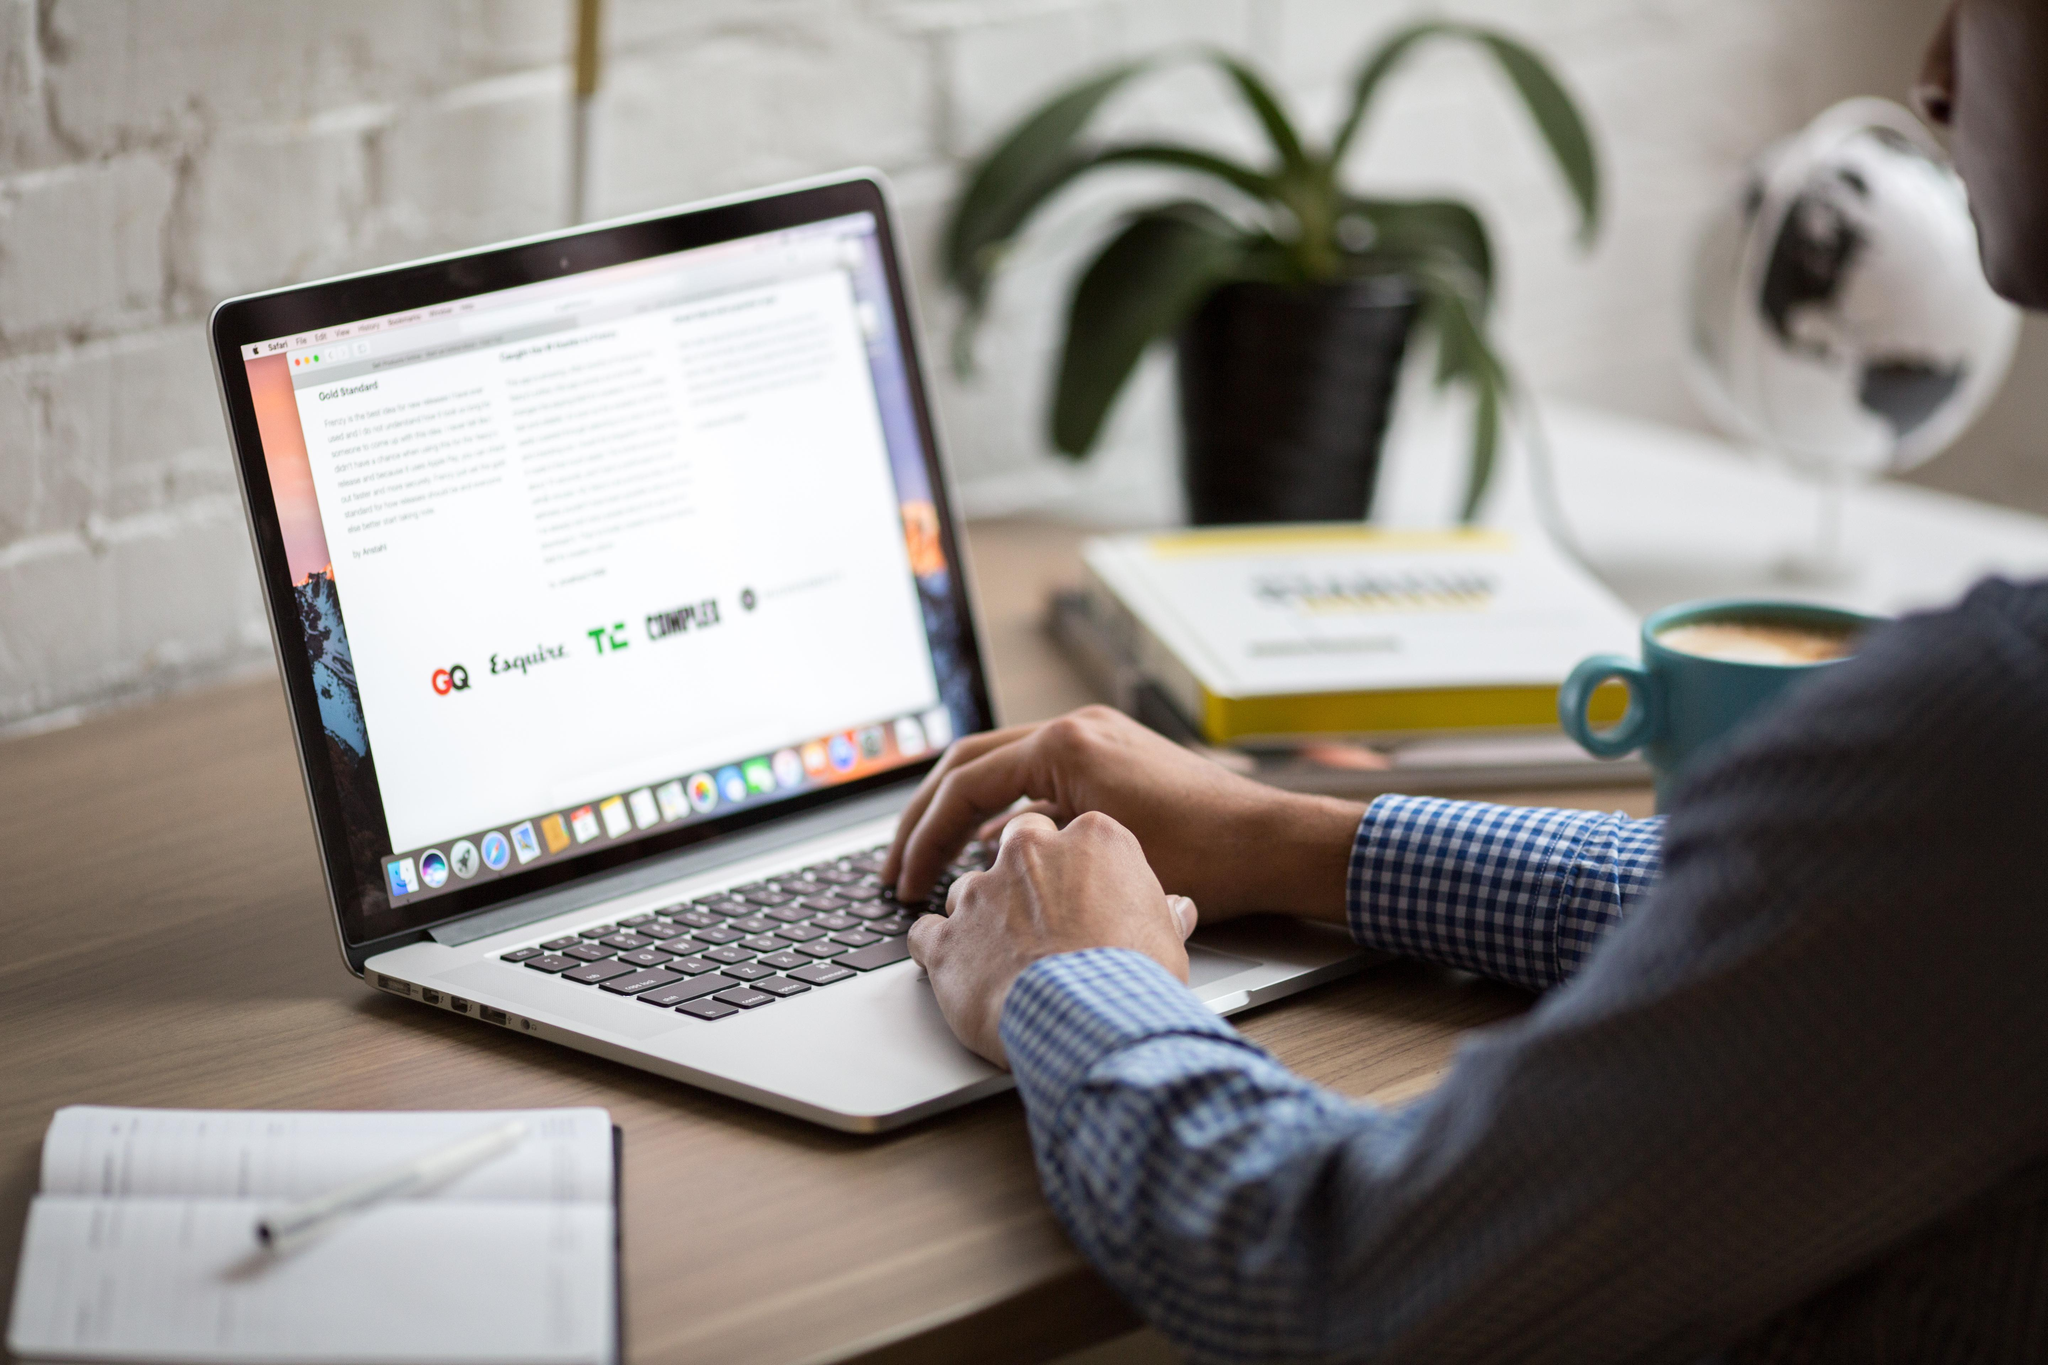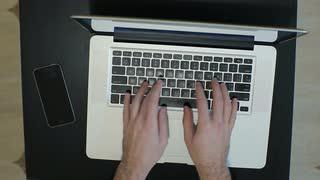The first image is the image on the left, the second image is the image on the right. Examine the images to the left and right. Is the description "In each image, a person's hands are on a laptop keyboard that has black keys on an otherwise light-colored surface." accurate? Answer yes or no. Yes. The first image is the image on the left, the second image is the image on the right. Given the left and right images, does the statement "Each image features a pair of hands over a keyboard, and the right image is an aerial view showing fingers over the black keyboard keys of one laptop." hold true? Answer yes or no. Yes. 